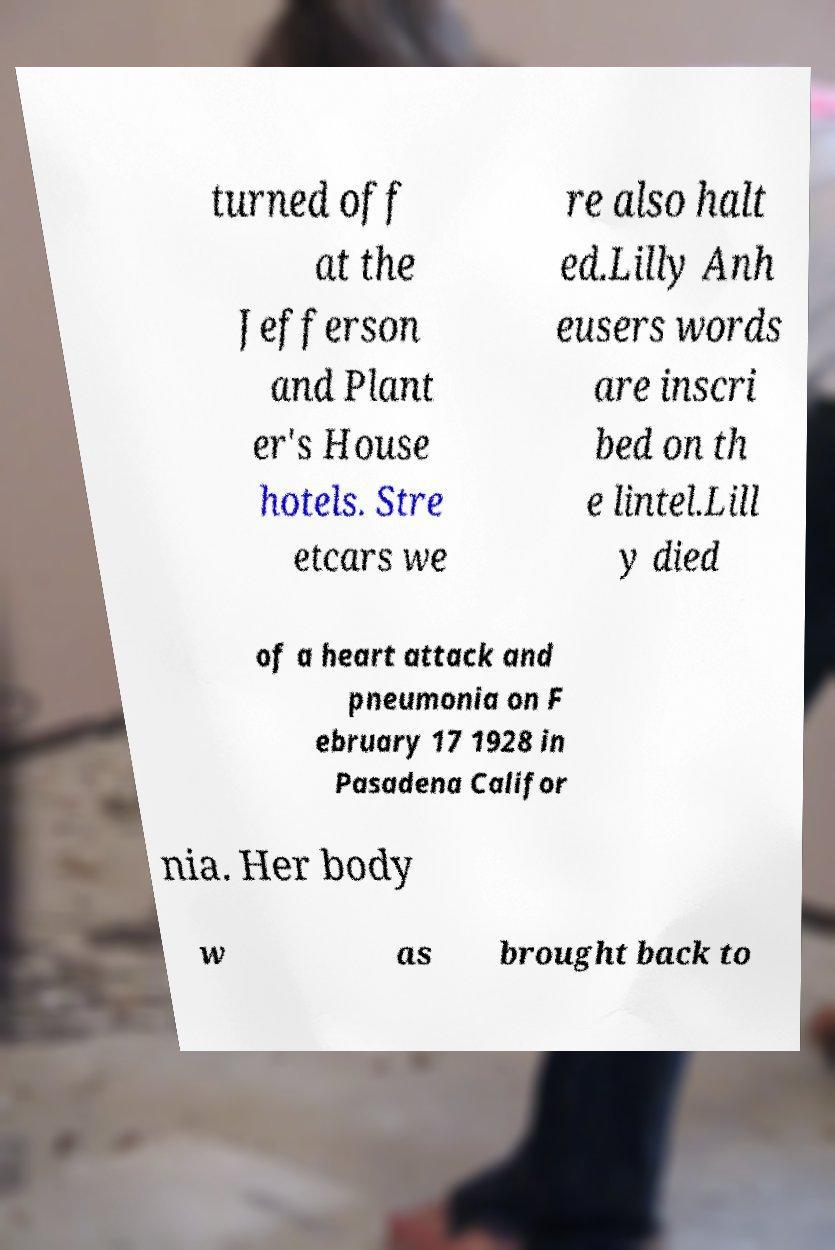Please identify and transcribe the text found in this image. turned off at the Jefferson and Plant er's House hotels. Stre etcars we re also halt ed.Lilly Anh eusers words are inscri bed on th e lintel.Lill y died of a heart attack and pneumonia on F ebruary 17 1928 in Pasadena Califor nia. Her body w as brought back to 